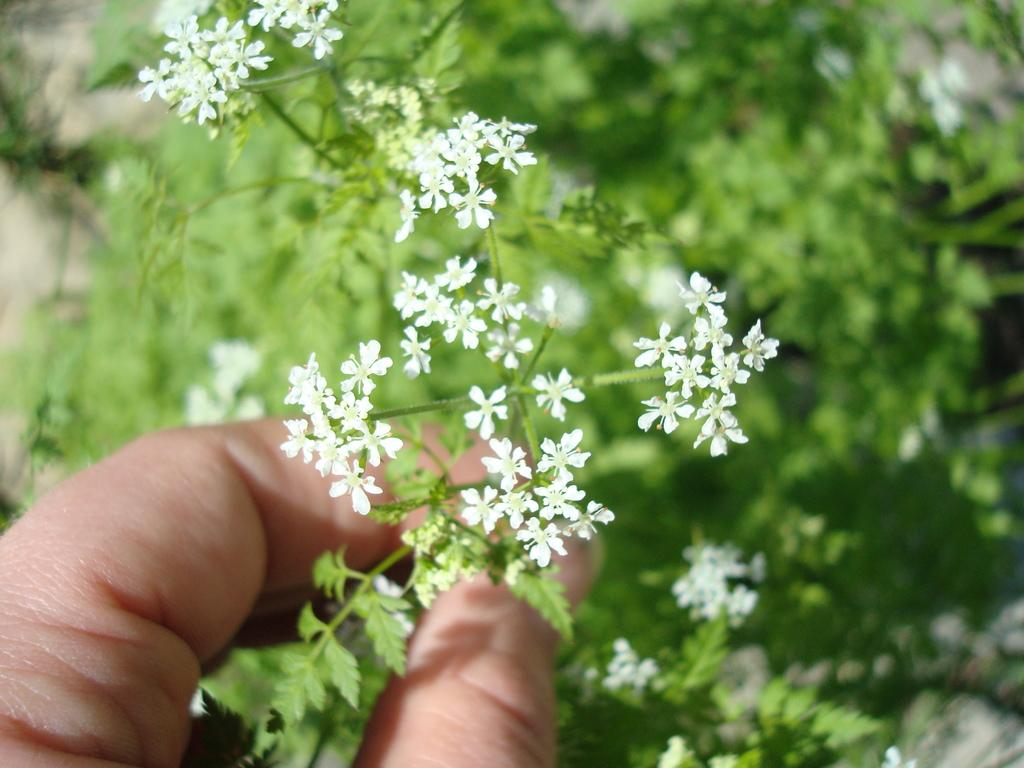What is being held in the human hand in the image? There is a plant being held in the human hand in the image. What can be observed about the plant? The plant has flowers, and they are white in color. The plant itself is green in color. Can you describe the background of the image? The background of the image is blurry. How many dogs are visible in the image? There are no dogs present in the image. What type of cheese is being offered to the plant in the image? There is no cheese present in the image; it features a human hand holding a plant with white flowers. 